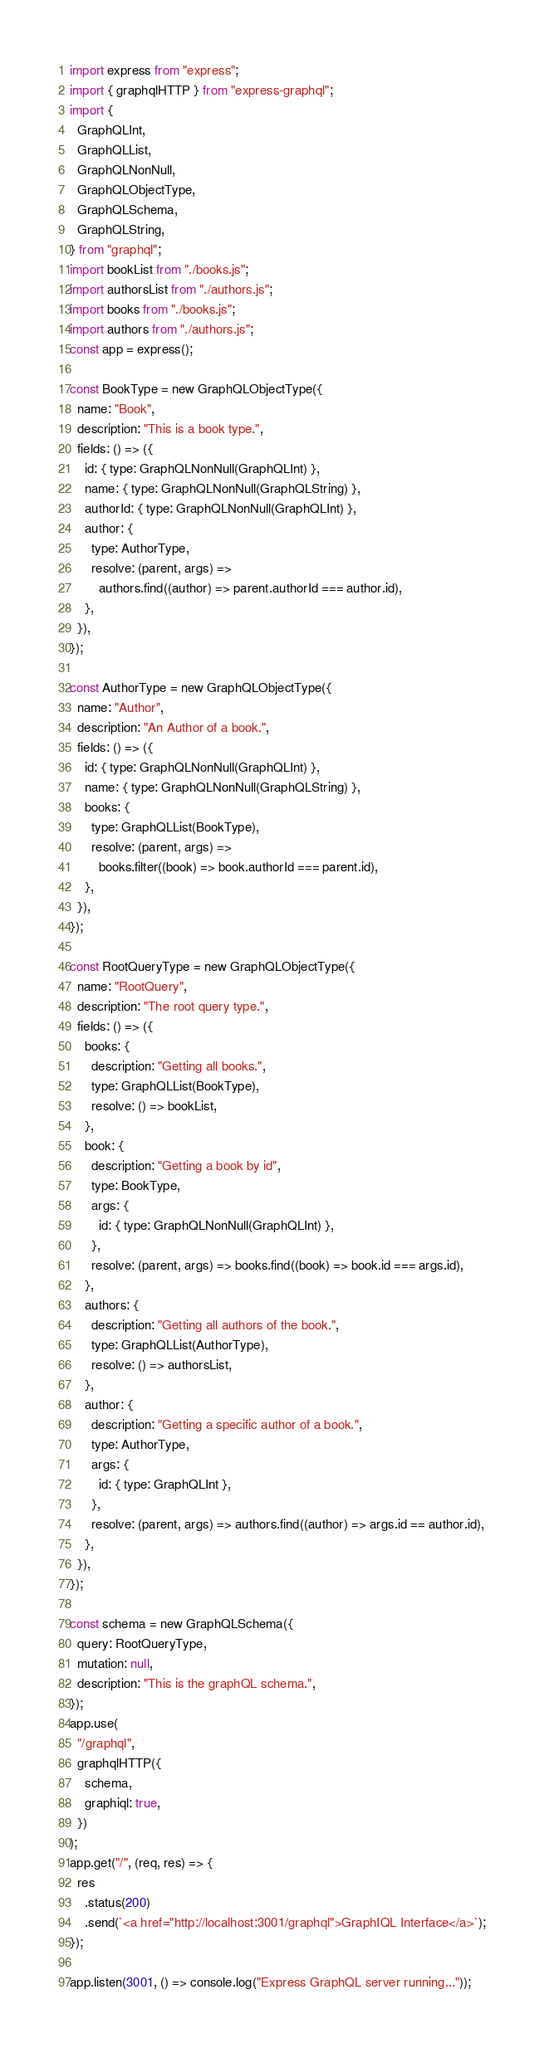<code> <loc_0><loc_0><loc_500><loc_500><_JavaScript_>import express from "express";
import { graphqlHTTP } from "express-graphql";
import {
  GraphQLInt,
  GraphQLList,
  GraphQLNonNull,
  GraphQLObjectType,
  GraphQLSchema,
  GraphQLString,
} from "graphql";
import bookList from "./books.js";
import authorsList from "./authors.js";
import books from "./books.js";
import authors from "./authors.js";
const app = express();

const BookType = new GraphQLObjectType({
  name: "Book",
  description: "This is a book type.",
  fields: () => ({
    id: { type: GraphQLNonNull(GraphQLInt) },
    name: { type: GraphQLNonNull(GraphQLString) },
    authorId: { type: GraphQLNonNull(GraphQLInt) },
    author: {
      type: AuthorType,
      resolve: (parent, args) =>
        authors.find((author) => parent.authorId === author.id),
    },
  }),
});

const AuthorType = new GraphQLObjectType({
  name: "Author",
  description: "An Author of a book.",
  fields: () => ({
    id: { type: GraphQLNonNull(GraphQLInt) },
    name: { type: GraphQLNonNull(GraphQLString) },
    books: {
      type: GraphQLList(BookType),
      resolve: (parent, args) =>
        books.filter((book) => book.authorId === parent.id),
    },
  }),
});

const RootQueryType = new GraphQLObjectType({
  name: "RootQuery",
  description: "The root query type.",
  fields: () => ({
    books: {
      description: "Getting all books.",
      type: GraphQLList(BookType),
      resolve: () => bookList,
    },
    book: {
      description: "Getting a book by id",
      type: BookType,
      args: {
        id: { type: GraphQLNonNull(GraphQLInt) },
      },
      resolve: (parent, args) => books.find((book) => book.id === args.id),
    },
    authors: {
      description: "Getting all authors of the book.",
      type: GraphQLList(AuthorType),
      resolve: () => authorsList,
    },
    author: {
      description: "Getting a specific author of a book.",
      type: AuthorType,
      args: {
        id: { type: GraphQLInt },
      },
      resolve: (parent, args) => authors.find((author) => args.id == author.id),
    },
  }),
});

const schema = new GraphQLSchema({
  query: RootQueryType,
  mutation: null,
  description: "This is the graphQL schema.",
});
app.use(
  "/graphql",
  graphqlHTTP({
    schema,
    graphiql: true,
  })
);
app.get("/", (req, res) => {
  res
    .status(200)
    .send(`<a href="http://localhost:3001/graphql">GraphIQL Interface</a>`);
});

app.listen(3001, () => console.log("Express GraphQL server running..."));
</code> 